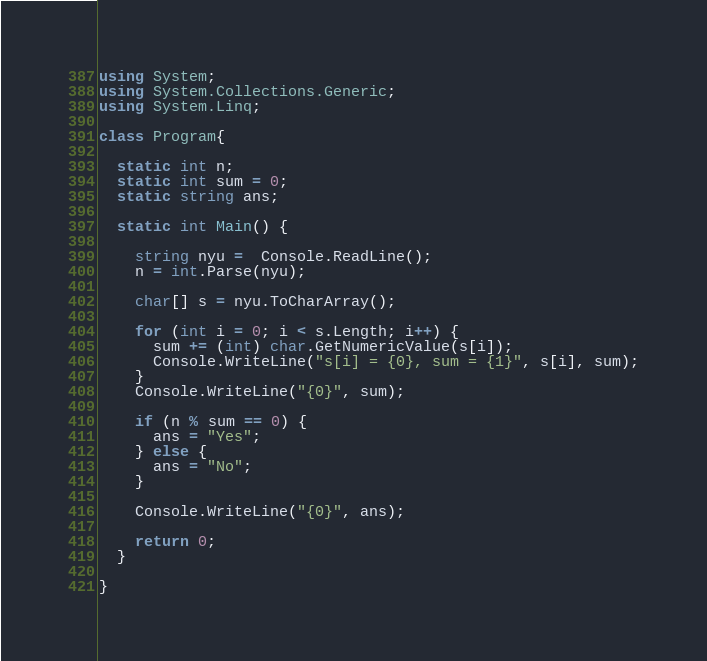<code> <loc_0><loc_0><loc_500><loc_500><_C#_>using System;
using System.Collections.Generic;
using System.Linq;

class Program{

  static int n;
  static int sum = 0;
  static string ans;

  static int Main() {

    string nyu =  Console.ReadLine();
    n = int.Parse(nyu);

    char[] s = nyu.ToCharArray();

    for (int i = 0; i < s.Length; i++) {
      sum += (int) char.GetNumericValue(s[i]);
      Console.WriteLine("s[i] = {0}, sum = {1}", s[i], sum);
    }
    Console.WriteLine("{0}", sum);

    if (n % sum == 0) {
      ans = "Yes";
    } else {
      ans = "No";
    }

    Console.WriteLine("{0}", ans);

    return 0;
  }

}
</code> 